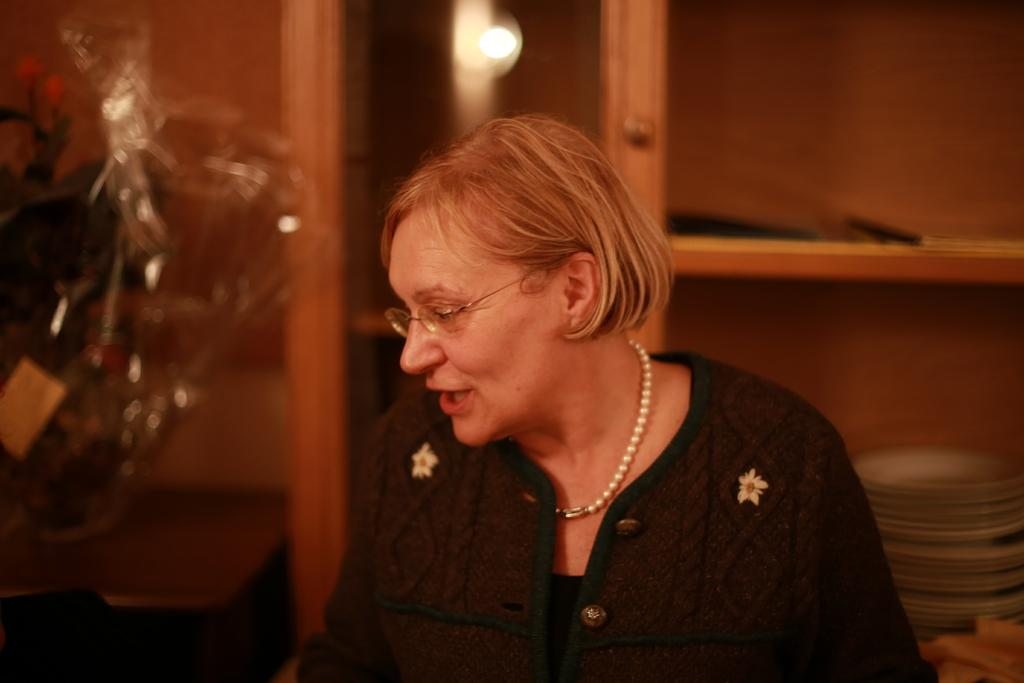Who is present in the image? There is a woman in the image. What can be seen on the table in the image? There is a bouquet on a table in the image. What is the source of light in the image? There is a light in the image. What objects are grouped together in the image? There is a group of plates in the image. Where are the books located in the image? The books are in a cupboard in the image. What type of machine is being used by the woman in the image? There is no machine present in the image; the woman is not using any machine. 